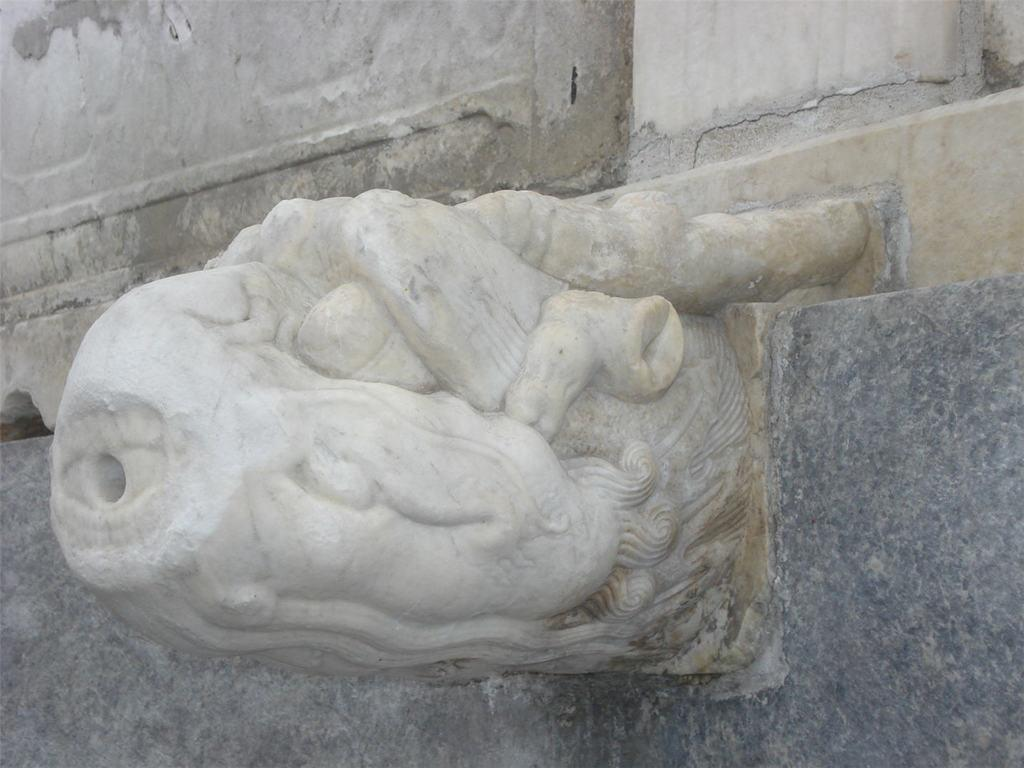What is the main subject of the image? There is a sculpture in the image. Where is the sculpture located? The sculpture is on the wall. What type of jeans is the sculpture wearing in the image? There is no mention of jeans or any clothing in the image, as the subject is a sculpture. 